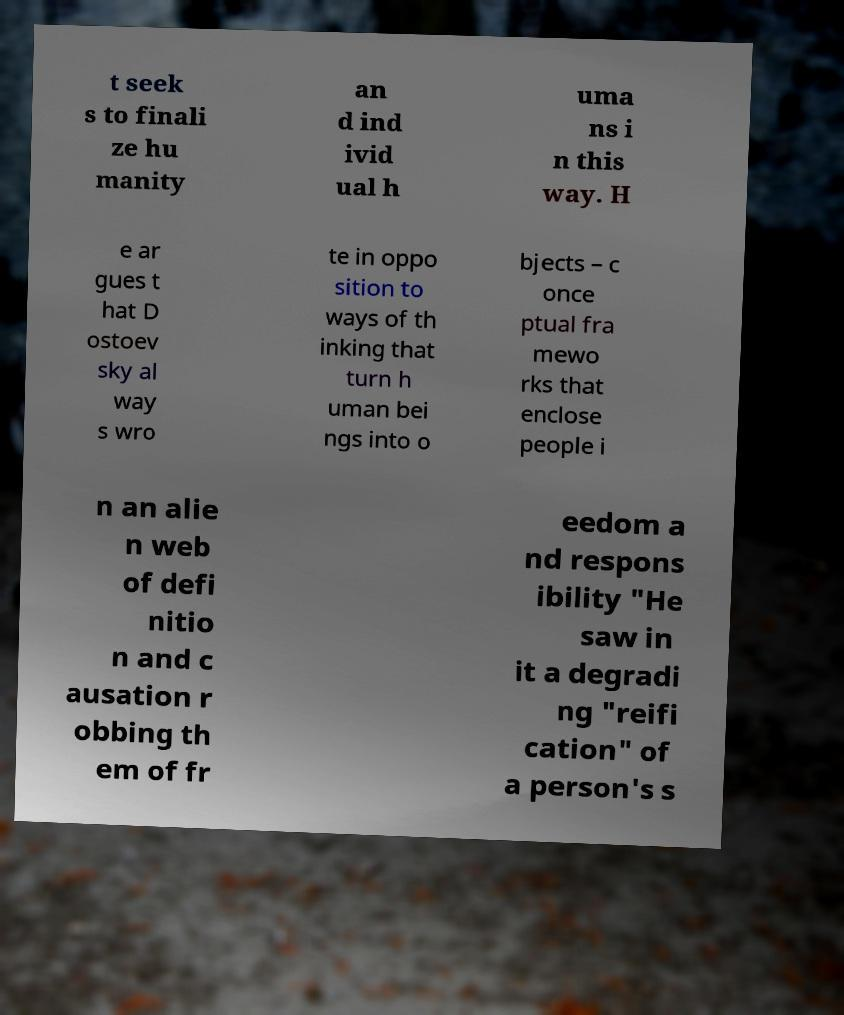There's text embedded in this image that I need extracted. Can you transcribe it verbatim? t seek s to finali ze hu manity an d ind ivid ual h uma ns i n this way. H e ar gues t hat D ostoev sky al way s wro te in oppo sition to ways of th inking that turn h uman bei ngs into o bjects – c once ptual fra mewo rks that enclose people i n an alie n web of defi nitio n and c ausation r obbing th em of fr eedom a nd respons ibility "He saw in it a degradi ng "reifi cation" of a person's s 